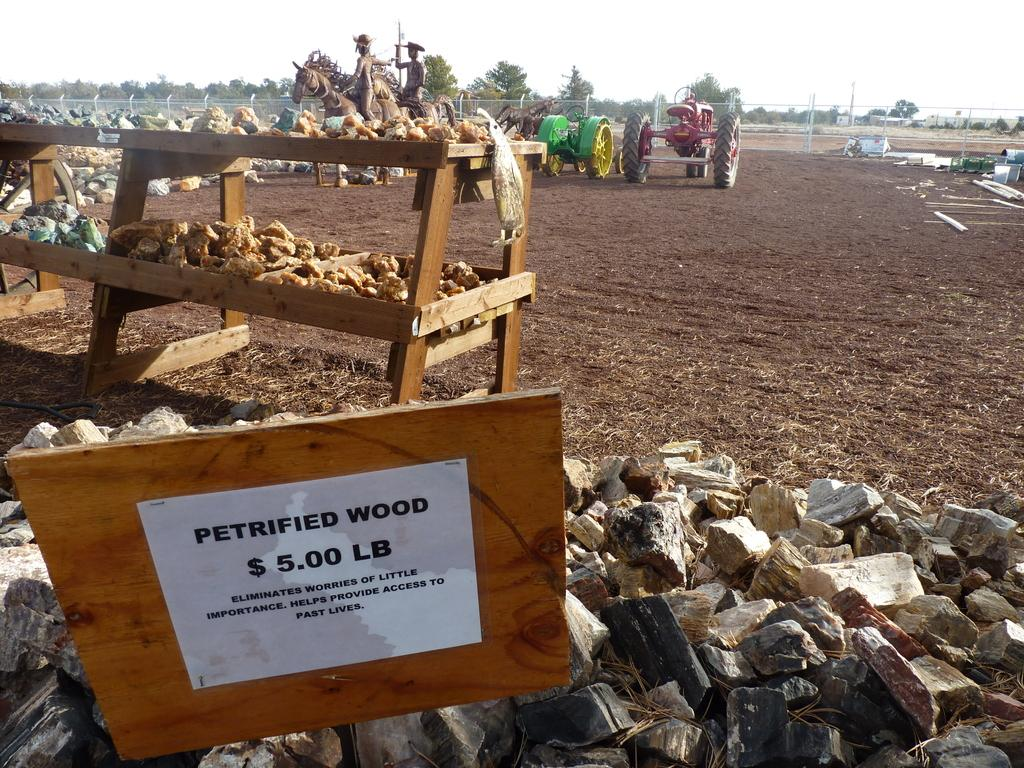<image>
Render a clear and concise summary of the photo. A sign offering petrified wood for five dollars a pound. 